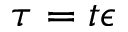<formula> <loc_0><loc_0><loc_500><loc_500>\tau = t \epsilon</formula> 